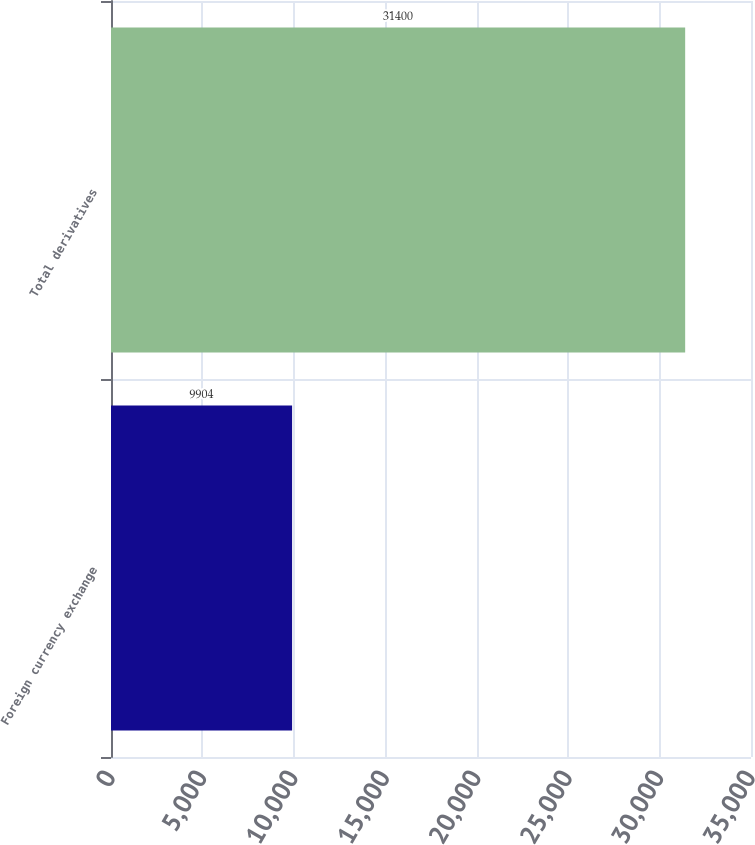<chart> <loc_0><loc_0><loc_500><loc_500><bar_chart><fcel>Foreign currency exchange<fcel>Total derivatives<nl><fcel>9904<fcel>31400<nl></chart> 